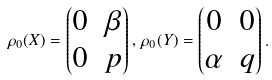<formula> <loc_0><loc_0><loc_500><loc_500>\rho _ { 0 } ( X ) = \begin{pmatrix} 0 & \beta \\ 0 & p \end{pmatrix} , \, \rho _ { 0 } ( Y ) = \begin{pmatrix} 0 & 0 \\ \alpha & q \end{pmatrix} .</formula> 